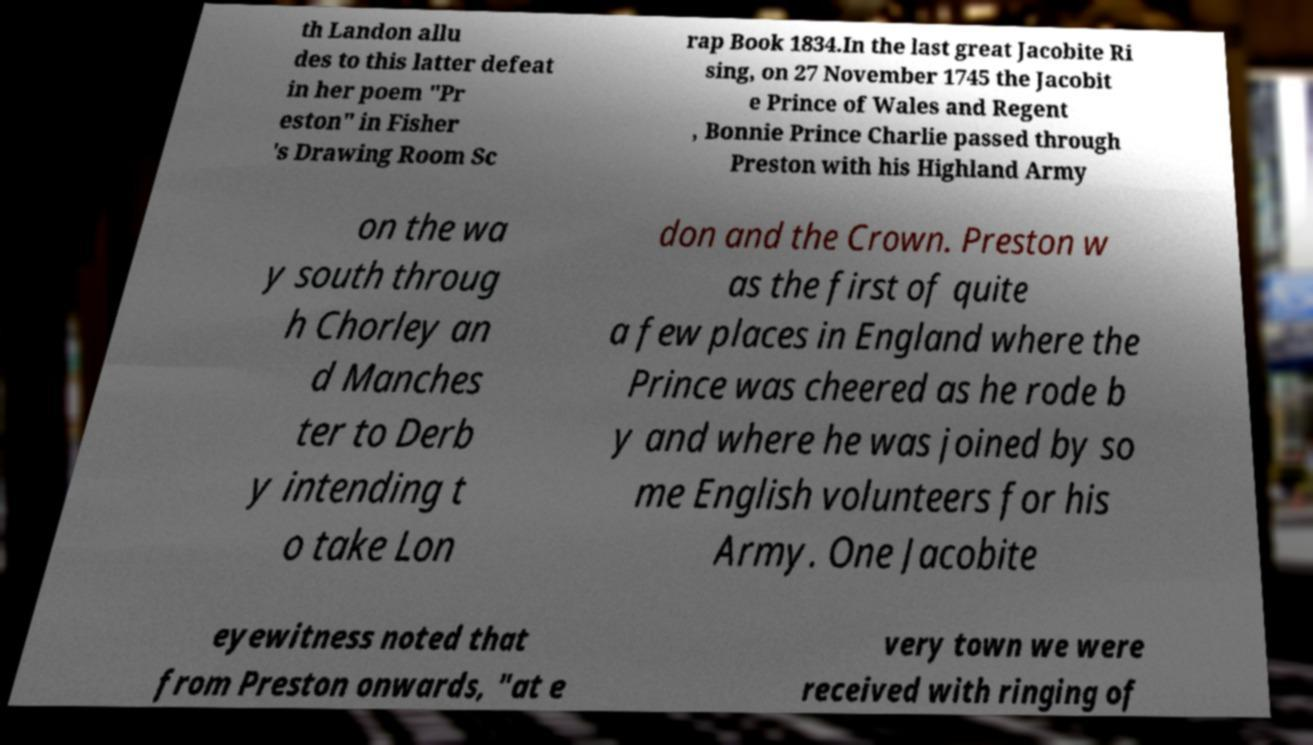There's text embedded in this image that I need extracted. Can you transcribe it verbatim? th Landon allu des to this latter defeat in her poem "Pr eston" in Fisher 's Drawing Room Sc rap Book 1834.In the last great Jacobite Ri sing, on 27 November 1745 the Jacobit e Prince of Wales and Regent , Bonnie Prince Charlie passed through Preston with his Highland Army on the wa y south throug h Chorley an d Manches ter to Derb y intending t o take Lon don and the Crown. Preston w as the first of quite a few places in England where the Prince was cheered as he rode b y and where he was joined by so me English volunteers for his Army. One Jacobite eyewitness noted that from Preston onwards, "at e very town we were received with ringing of 